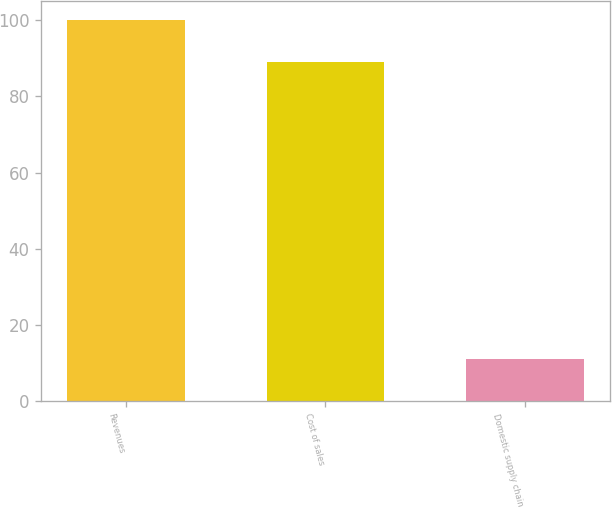<chart> <loc_0><loc_0><loc_500><loc_500><bar_chart><fcel>Revenues<fcel>Cost of sales<fcel>Domestic supply chain<nl><fcel>100<fcel>88.9<fcel>11.1<nl></chart> 